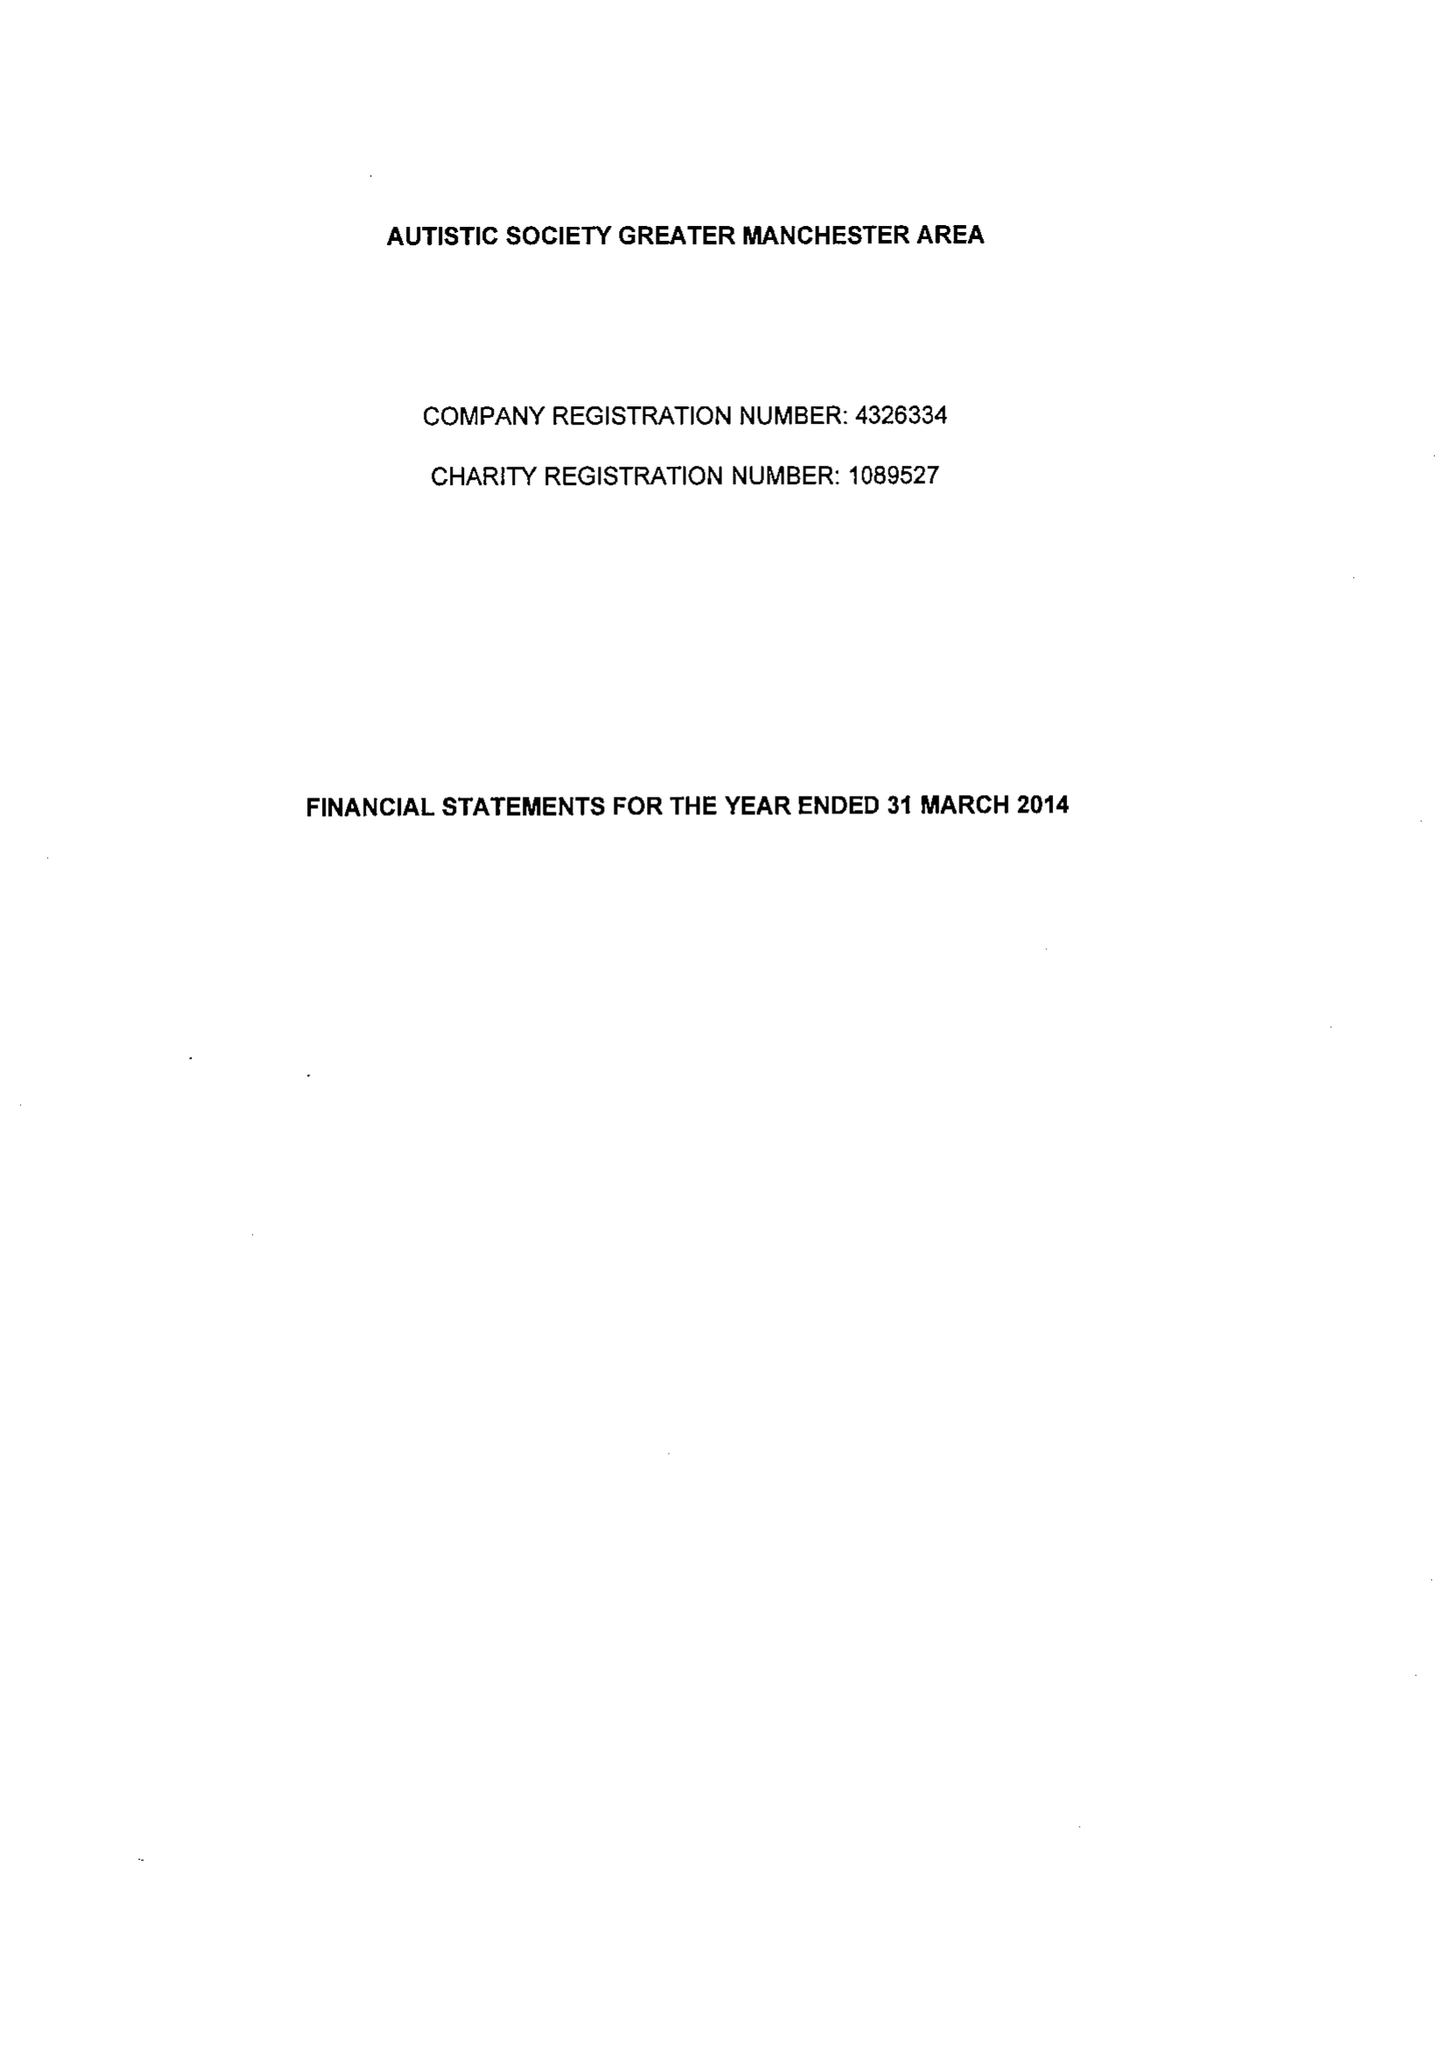What is the value for the address__post_town?
Answer the question using a single word or phrase. MANCHESTER 